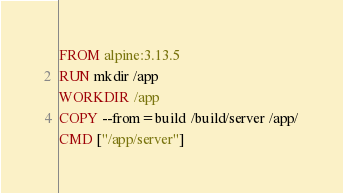<code> <loc_0><loc_0><loc_500><loc_500><_Dockerfile_>
FROM alpine:3.13.5
RUN mkdir /app
WORKDIR /app
COPY --from=build /build/server /app/
CMD ["/app/server"]

</code> 